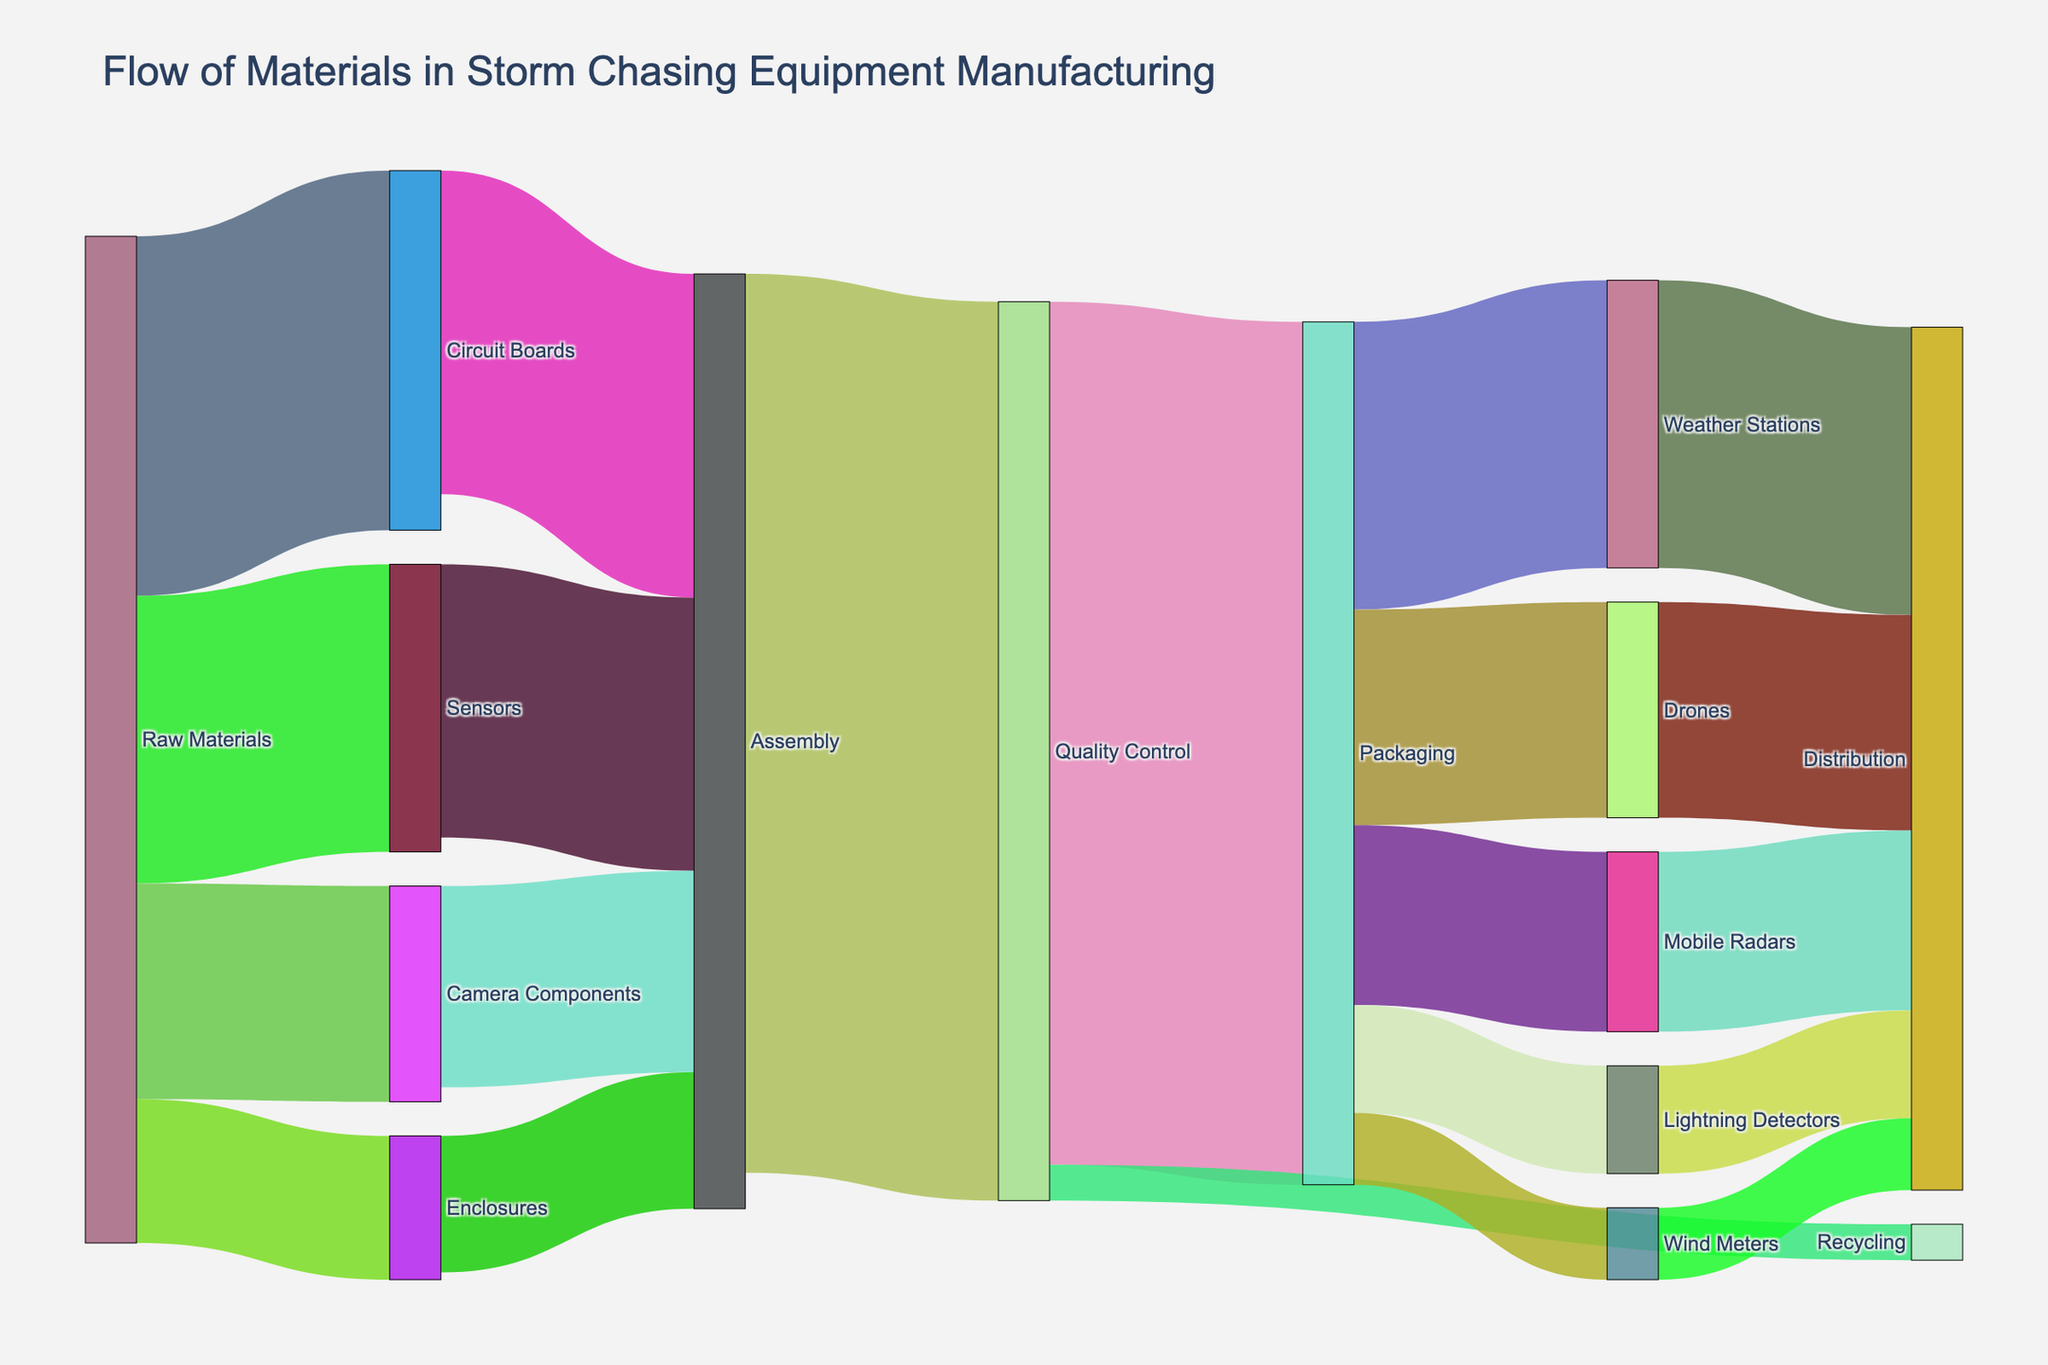How many different categories of materials flow into the Assembly stage? To determine the number of different categories of materials flowing into the Assembly stage, observe the diagram's links directed into the "Assembly" node. These originating nodes are "Circuit Boards," "Sensors," "Camera Components," and "Enclosures," representing four categories.
Answer: 4 What is the total quantity of materials that pass through Quality Control? Consider the flows entering the "Quality Control" node. The values from "Assembly" to "Quality Control" are 1250. The total amount is the sum of all materials passing through "Quality Control."
Answer: 1250 How much material goes to Recycling after Quality Control? The flow from "Quality Control" to "Recycling" node shows a value of 50 units. This is directly visible in the diagram.
Answer: 50 Which end product receives the largest quantity of materials from Packaging? Look at the flows from the "Packaging" node to the different end product nodes - "Weather Stations," "Drones," "Mobile Radars," "Lightning Detectors," and "Wind Meters." "Weather Stations" receive the largest amount, 400 units.
Answer: Weather Stations Compare the total quantity of raw materials distributed between Enclosures and Sensors. Which one is greater? The Raw Materials flow into "Enclosures" is 200 units and into "Sensors" is 400 units. Comparing these amounts shows that "Sensors" receive a greater quantity.
Answer: Sensors What proportion of materials going to Weather Stations is compared to the total materials from Packaging? First, identify the total materials from "Packaging" to all targets, which sums up to 1200 (400 + 300 + 250 + 150 + 100). The material going to "Weather Stations" is 400. The proportion is thus 400/1200 = 1/3.
Answer: 1/3 After Quality Control, how much more material goes to Packaging compared to Recycling? Observe the flows from "Quality Control" to "Packaging" and "Recycling." Packaging receives 1200 units, and Recycling receives 50 units. The difference is 1200 - 50 = 1150 units.
Answer: 1150 Which products eventually lead to Distribution and what are their individual quantities? Check the flows going to the "Distribution" node. These flows originate from "Weather Stations" (400), "Drones" (300), "Mobile Radars" (250), "Lightning Detectors" (150), "Wind Meters" (100). Each product contributes these respective quantities to Distribution.
Answer: Weather Stations: 400, Drones: 300, Mobile Radars: 250, Lightning Detectors: 150, Wind Meters: 100 